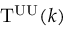<formula> <loc_0><loc_0><loc_500><loc_500>T ^ { U U } ( k )</formula> 